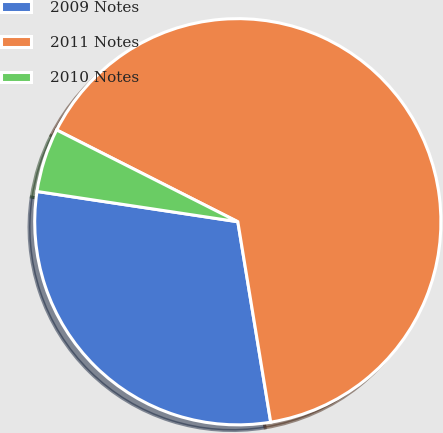Convert chart. <chart><loc_0><loc_0><loc_500><loc_500><pie_chart><fcel>2009 Notes<fcel>2011 Notes<fcel>2010 Notes<nl><fcel>29.97%<fcel>64.94%<fcel>5.08%<nl></chart> 